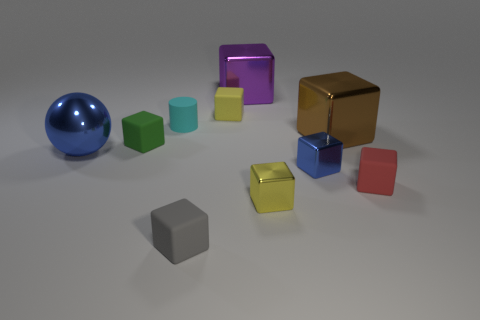Is there any other thing that has the same shape as the cyan thing?
Ensure brevity in your answer.  No. Are the large purple object and the big object that is right of the blue metal block made of the same material?
Offer a terse response. Yes. How many other things are the same size as the yellow rubber cube?
Provide a succinct answer. 6. There is a tiny cube that is left of the small rubber object in front of the small yellow metallic object; are there any large shiny cubes that are to the left of it?
Make the answer very short. No. The cyan matte thing has what size?
Offer a terse response. Small. What is the size of the cylinder that is on the left side of the tiny red cube?
Give a very brief answer. Small. There is a blue thing on the right side of the green matte object; is its size the same as the small yellow metal object?
Make the answer very short. Yes. Is there anything else that has the same color as the rubber cylinder?
Keep it short and to the point. No. There is a tiny green thing; what shape is it?
Keep it short and to the point. Cube. What number of shiny cubes are both behind the tiny matte cylinder and in front of the big metallic ball?
Your answer should be very brief. 0. 